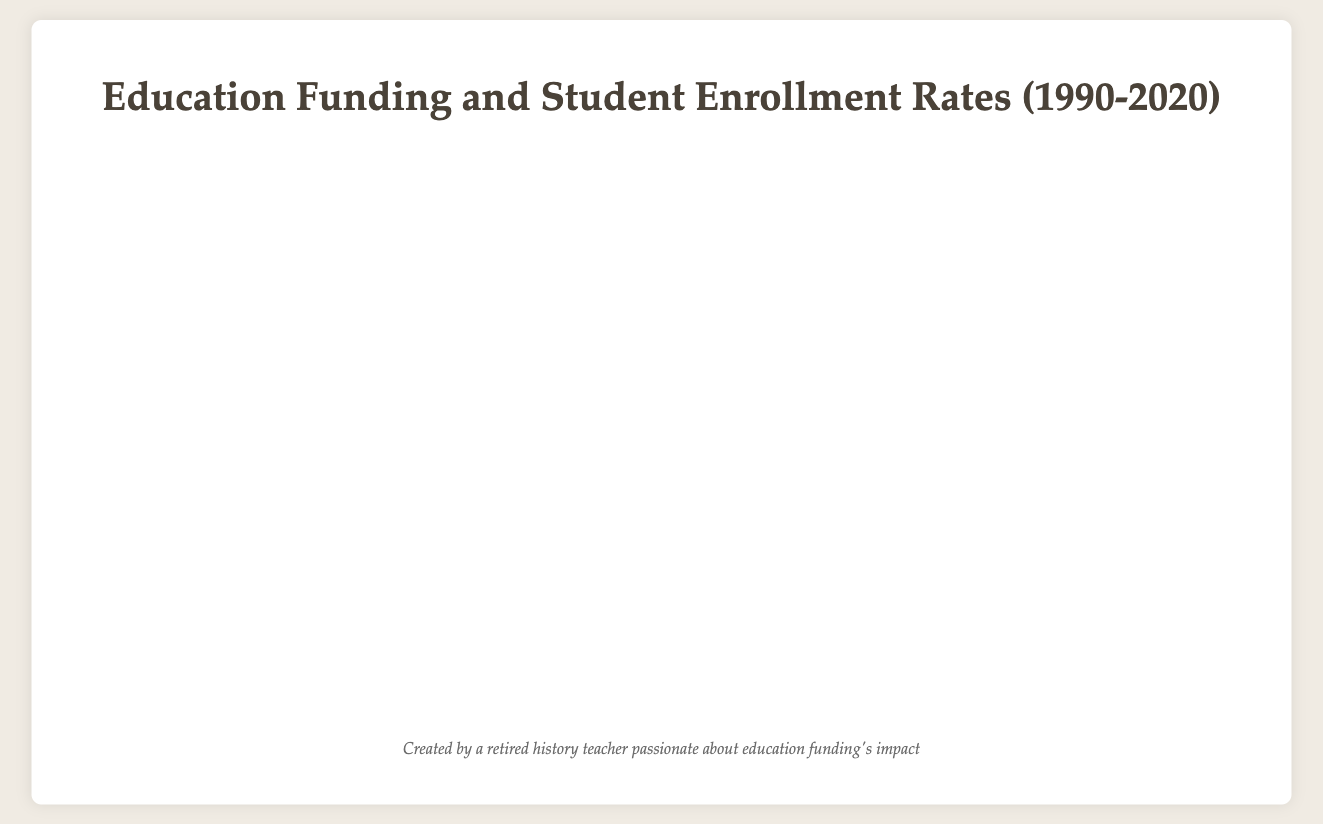What is the general relationship between education funding and student enrollment rates across regions? Generally, as education funding increases, student enrollment rates also increase. This is visible as most bubbles move towards higher funding and higher enrollment rates over the years.
Answer: Positive correlation Which region had the highest student enrollment rate in 2020? The bubble representing North America in 2020 is positioned at the highest point on the y-axis of the chart, indicating the highest student enrollment rate of 95%.
Answer: North America How has the funding for education in South America changed from 1990 to 2020? In 1990, the funding for South America was $200,000,000. By 2020, it increased to $400,000,000. This shows an increase of $200,000,000 over 30 years.
Answer: Increased by $200,000,000 Compare the student enrollment rate between Asia and Europe in 2010. The bubble representing Asia in 2010 has a student enrollment rate at the y-axis position of 89%, while Europe in 2010 is at 91%. Europe has a slightly higher enrollment rate than Asia in 2010.
Answer: Europe has a higher rate What is the average student enrollment rate in Africa from 1990 to 2020? Student enrollment rates for Africa are 60% (1990), 68% (2000), 75% (2010), and 80% (2020). Sum these rates: 60 + 68 + 75 + 80 = 283. Average is 283 / 4 = 70.75%.
Answer: 70.75% Which region had the smallest increase in education funding from 1990 to 2020? Calculating the funding increase: North America (820,000 - 500,000 = 320,000), Europe (700,000 - 450,000 = 250,000), Asia (610,000 - 300,000 = 310,000), Africa (320,000 - 100,000 = 220,000), and South America (400,000 - 200,000 = 200,000). The smallest increase is in South America.
Answer: South America How has the student enrollment rate in North America changed over the decades? North America enrollment rates: 85% (1990), 90% (2000), 93% (2010), 95% (2020). This shows a consistent increase each decade.
Answer: Consistent increase Which region had the lowest funding for education in 1990, and what was its student enrollment rate? The bubble for Africa in 1990 has the smallest x-coordinate value, indicating the lowest funding ($100,000,000), with a student enrollment rate of 60%.
Answer: Africa, 60% How does the funding in Europe in 2000 compare to that in North America in the same year? Europe’s funding in 2000 was $520,000,000, while North America's was $650,000,000. Therefore, North America had higher funding compared to Europe.
Answer: North America had higher funding What is the trend in funding for education in Asia over the years from 1990 to 2020? The bubbles for Asia in 1990, 2000, 2010, and 2020 show a gradually increasing position along the x-axis, indicating an increase in funding from $300,000,000 to $610,000,000.
Answer: Increasing trend 